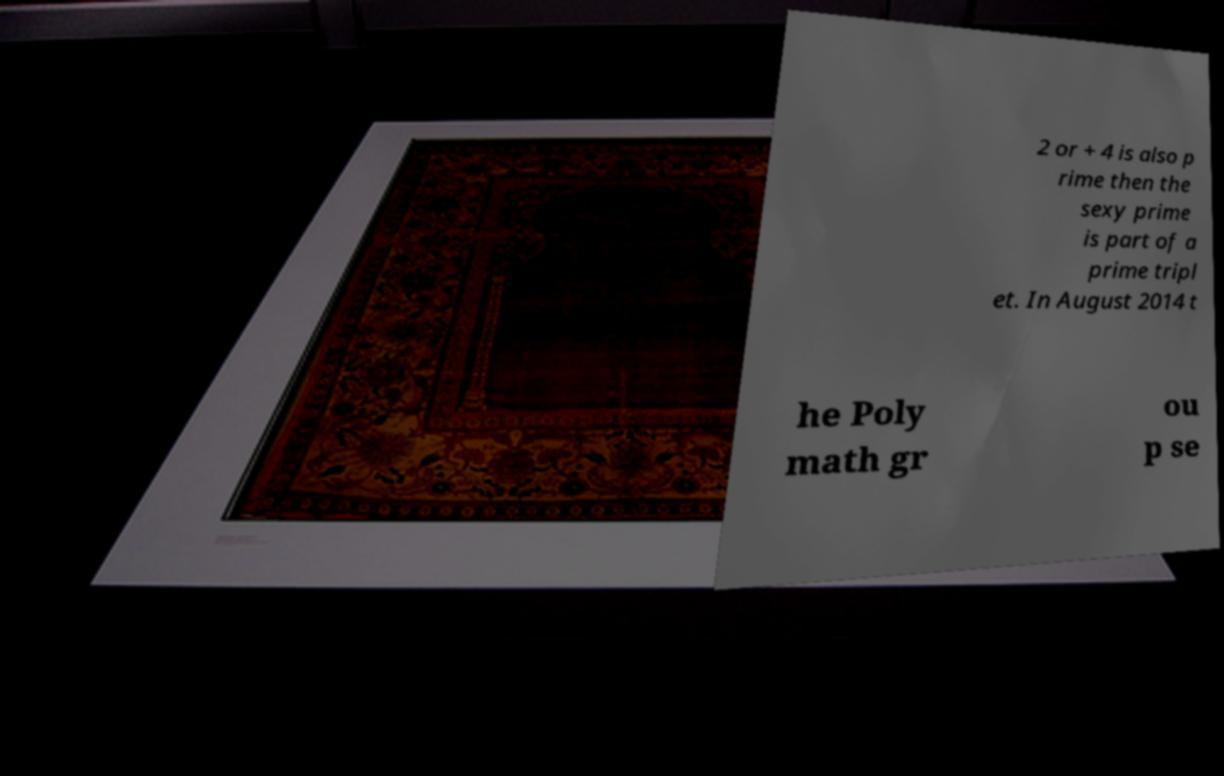What messages or text are displayed in this image? I need them in a readable, typed format. 2 or + 4 is also p rime then the sexy prime is part of a prime tripl et. In August 2014 t he Poly math gr ou p se 